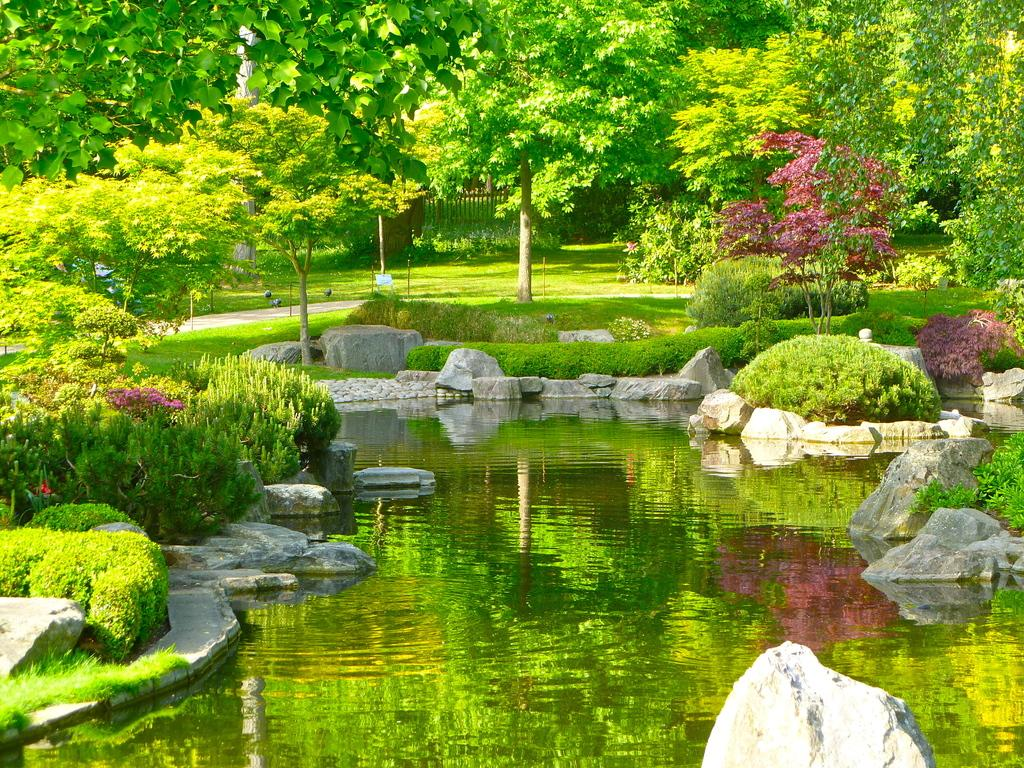What type of vegetation can be seen in the image? There are trees and plants in the image. What type of natural elements are present in the image? There are stones and water visible in the image. What can be seen in the background of the image? There is fencing in the background of the image. What type of curve can be seen in the wilderness in the image? There is no wilderness or curve present in the image. 